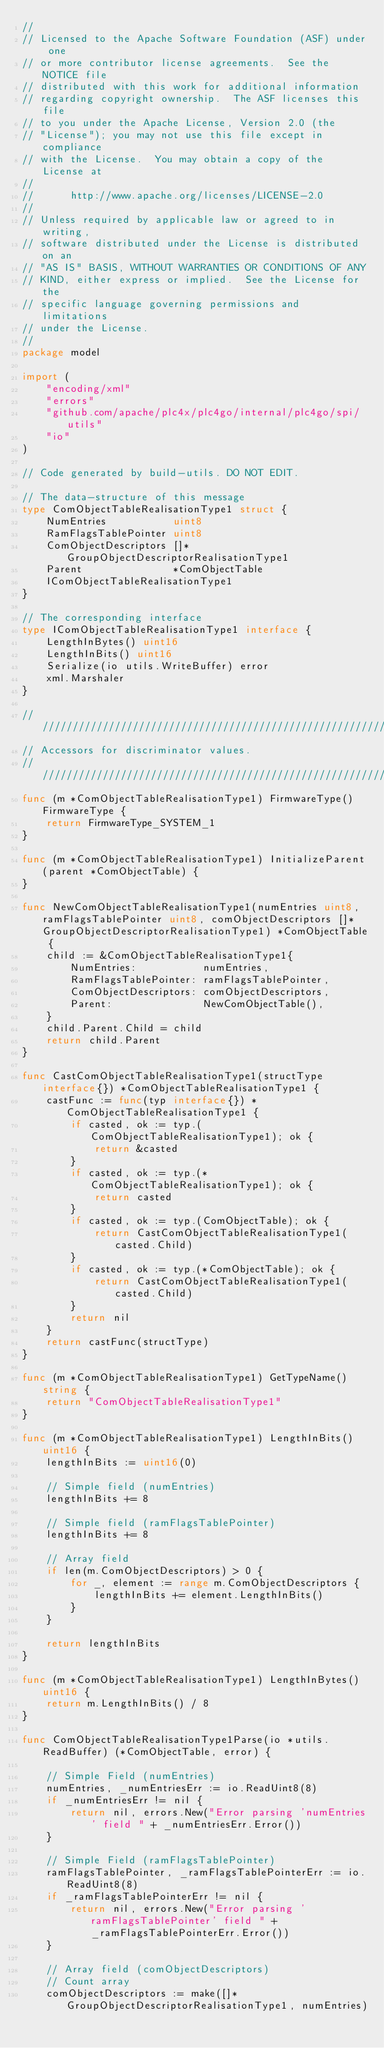<code> <loc_0><loc_0><loc_500><loc_500><_Go_>//
// Licensed to the Apache Software Foundation (ASF) under one
// or more contributor license agreements.  See the NOTICE file
// distributed with this work for additional information
// regarding copyright ownership.  The ASF licenses this file
// to you under the Apache License, Version 2.0 (the
// "License"); you may not use this file except in compliance
// with the License.  You may obtain a copy of the License at
//
//      http://www.apache.org/licenses/LICENSE-2.0
//
// Unless required by applicable law or agreed to in writing,
// software distributed under the License is distributed on an
// "AS IS" BASIS, WITHOUT WARRANTIES OR CONDITIONS OF ANY
// KIND, either express or implied.  See the License for the
// specific language governing permissions and limitations
// under the License.
//
package model

import (
	"encoding/xml"
	"errors"
	"github.com/apache/plc4x/plc4go/internal/plc4go/spi/utils"
	"io"
)

// Code generated by build-utils. DO NOT EDIT.

// The data-structure of this message
type ComObjectTableRealisationType1 struct {
	NumEntries           uint8
	RamFlagsTablePointer uint8
	ComObjectDescriptors []*GroupObjectDescriptorRealisationType1
	Parent               *ComObjectTable
	IComObjectTableRealisationType1
}

// The corresponding interface
type IComObjectTableRealisationType1 interface {
	LengthInBytes() uint16
	LengthInBits() uint16
	Serialize(io utils.WriteBuffer) error
	xml.Marshaler
}

///////////////////////////////////////////////////////////
// Accessors for discriminator values.
///////////////////////////////////////////////////////////
func (m *ComObjectTableRealisationType1) FirmwareType() FirmwareType {
	return FirmwareType_SYSTEM_1
}

func (m *ComObjectTableRealisationType1) InitializeParent(parent *ComObjectTable) {
}

func NewComObjectTableRealisationType1(numEntries uint8, ramFlagsTablePointer uint8, comObjectDescriptors []*GroupObjectDescriptorRealisationType1) *ComObjectTable {
	child := &ComObjectTableRealisationType1{
		NumEntries:           numEntries,
		RamFlagsTablePointer: ramFlagsTablePointer,
		ComObjectDescriptors: comObjectDescriptors,
		Parent:               NewComObjectTable(),
	}
	child.Parent.Child = child
	return child.Parent
}

func CastComObjectTableRealisationType1(structType interface{}) *ComObjectTableRealisationType1 {
	castFunc := func(typ interface{}) *ComObjectTableRealisationType1 {
		if casted, ok := typ.(ComObjectTableRealisationType1); ok {
			return &casted
		}
		if casted, ok := typ.(*ComObjectTableRealisationType1); ok {
			return casted
		}
		if casted, ok := typ.(ComObjectTable); ok {
			return CastComObjectTableRealisationType1(casted.Child)
		}
		if casted, ok := typ.(*ComObjectTable); ok {
			return CastComObjectTableRealisationType1(casted.Child)
		}
		return nil
	}
	return castFunc(structType)
}

func (m *ComObjectTableRealisationType1) GetTypeName() string {
	return "ComObjectTableRealisationType1"
}

func (m *ComObjectTableRealisationType1) LengthInBits() uint16 {
	lengthInBits := uint16(0)

	// Simple field (numEntries)
	lengthInBits += 8

	// Simple field (ramFlagsTablePointer)
	lengthInBits += 8

	// Array field
	if len(m.ComObjectDescriptors) > 0 {
		for _, element := range m.ComObjectDescriptors {
			lengthInBits += element.LengthInBits()
		}
	}

	return lengthInBits
}

func (m *ComObjectTableRealisationType1) LengthInBytes() uint16 {
	return m.LengthInBits() / 8
}

func ComObjectTableRealisationType1Parse(io *utils.ReadBuffer) (*ComObjectTable, error) {

	// Simple Field (numEntries)
	numEntries, _numEntriesErr := io.ReadUint8(8)
	if _numEntriesErr != nil {
		return nil, errors.New("Error parsing 'numEntries' field " + _numEntriesErr.Error())
	}

	// Simple Field (ramFlagsTablePointer)
	ramFlagsTablePointer, _ramFlagsTablePointerErr := io.ReadUint8(8)
	if _ramFlagsTablePointerErr != nil {
		return nil, errors.New("Error parsing 'ramFlagsTablePointer' field " + _ramFlagsTablePointerErr.Error())
	}

	// Array field (comObjectDescriptors)
	// Count array
	comObjectDescriptors := make([]*GroupObjectDescriptorRealisationType1, numEntries)</code> 